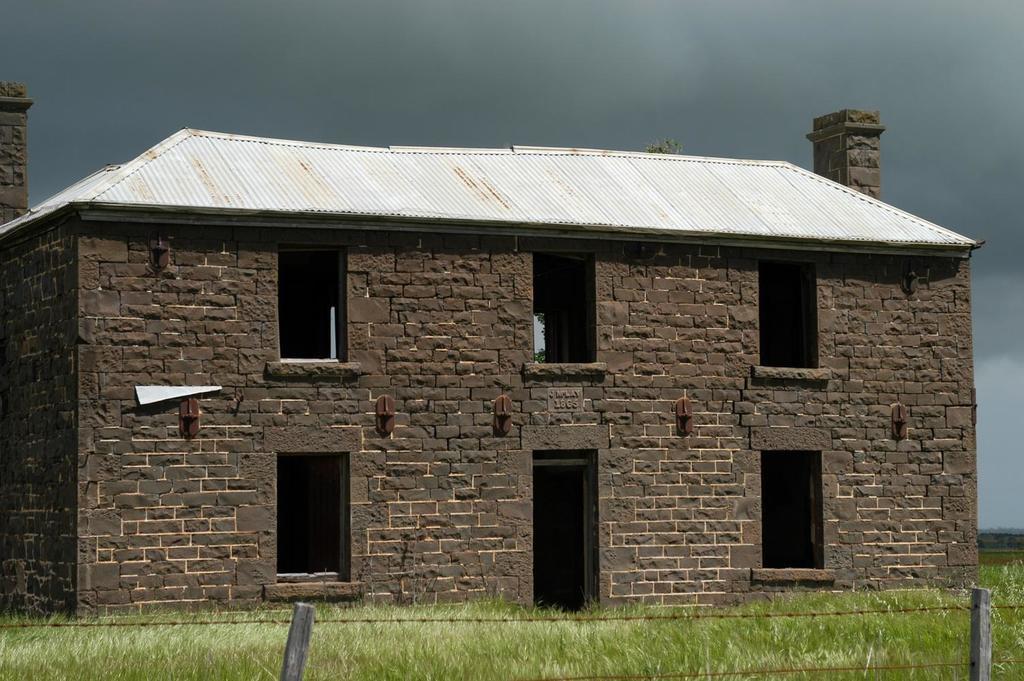Describe this image in one or two sentences. In this picture I can see a house, there is grass, fence, and in the background there is sky. 